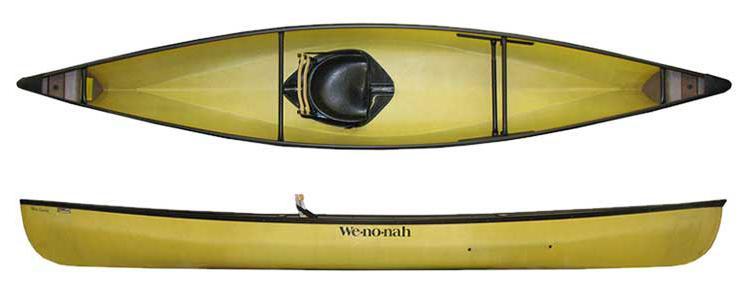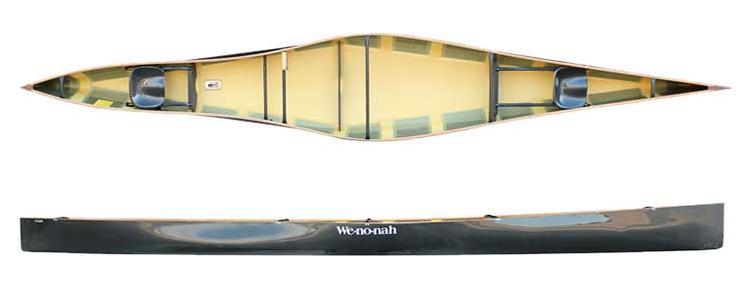The first image is the image on the left, the second image is the image on the right. Evaluate the accuracy of this statement regarding the images: "Both images show two views of a yellow-bodied canoe, and one features at least one woven black seat inside the canoe.". Is it true? Answer yes or no. No. The first image is the image on the left, the second image is the image on the right. Considering the images on both sides, is "There is one canoe in each image, and they are all the same color inside as out." valid? Answer yes or no. No. 